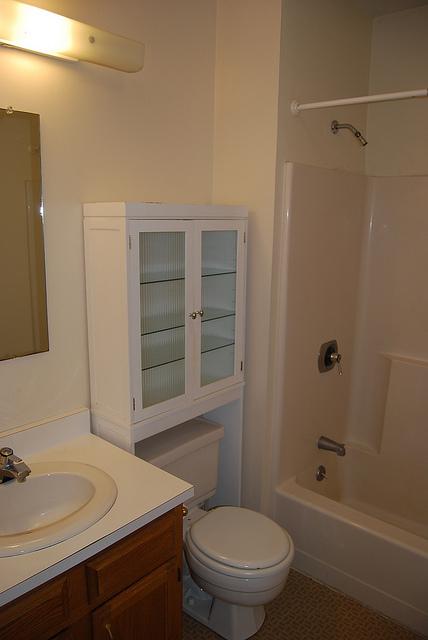Is there liquid soap on the sink?
Write a very short answer. No. How many power outlets can be seen?
Keep it brief. 0. What color is the cabinet above the toilet?
Quick response, please. White. What is over the toilet tank?
Keep it brief. Cabinet. What is along the side of the bathtub?
Concise answer only. Toilet. Are there any tissues?
Short answer required. No. What type of light bulb is on in this picture?
Quick response, please. Fluorescent. Is the shower a regular shower?
Quick response, please. Yes. What is the wall made of?
Answer briefly. Drywall. How many shelves are in the cabinet with the glass doors?
Be succinct. 4. How many lights are above the mirror?
Concise answer only. 1. Is there a cabinet under the basin?
Quick response, please. Yes. Are there cabinet doors beneath the sink?
Concise answer only. Yes. Is this room clean?
Keep it brief. Yes. Is the toilet seat open?
Quick response, please. No. 